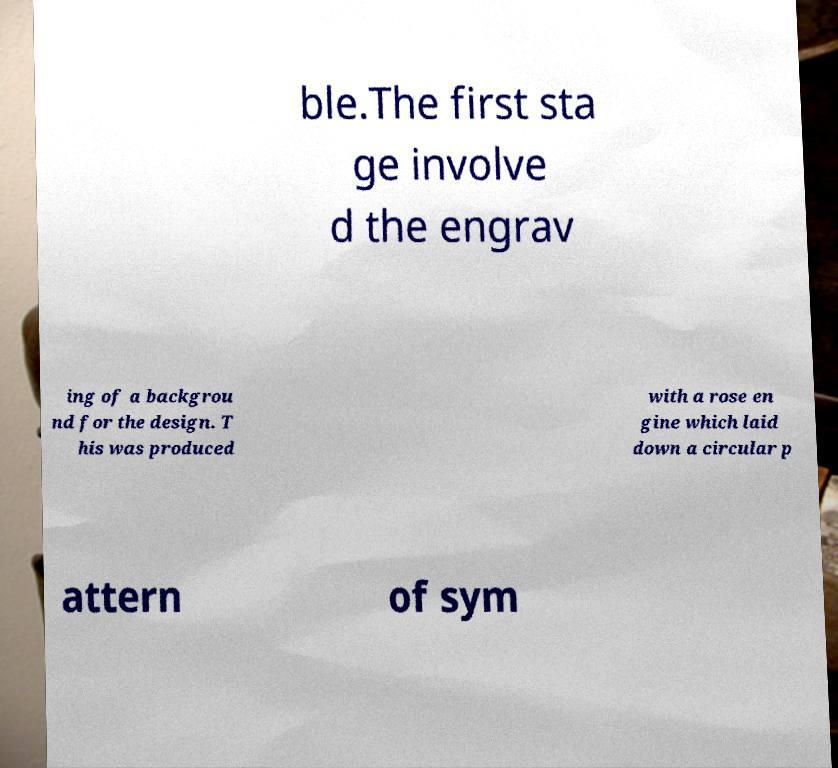Please identify and transcribe the text found in this image. ble.The first sta ge involve d the engrav ing of a backgrou nd for the design. T his was produced with a rose en gine which laid down a circular p attern of sym 